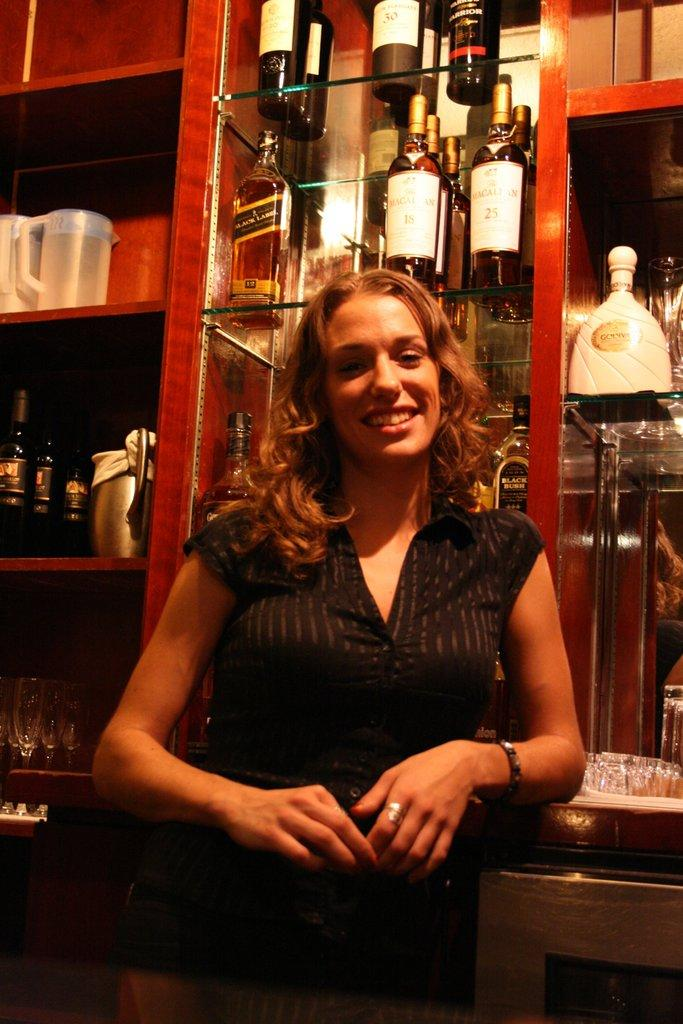Who is the main subject in the image? There is a woman in the image. What is the woman doing in the image? The woman is smiling and facing a camera. What can be seen behind the woman in the image? There are many drink bottles visible behind the woman. What type of wax is being used to create the woman's smile in the image? There is no wax present in the image, and the woman's smile is a natural expression. 